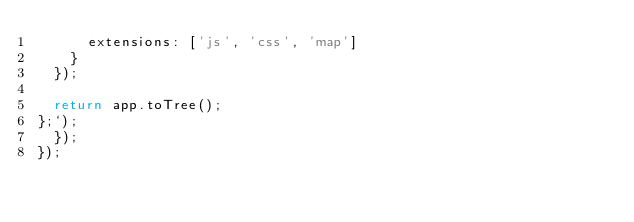<code> <loc_0><loc_0><loc_500><loc_500><_JavaScript_>      extensions: ['js', 'css', 'map']
    }
  });

  return app.toTree();
};`);
  });
});
</code> 